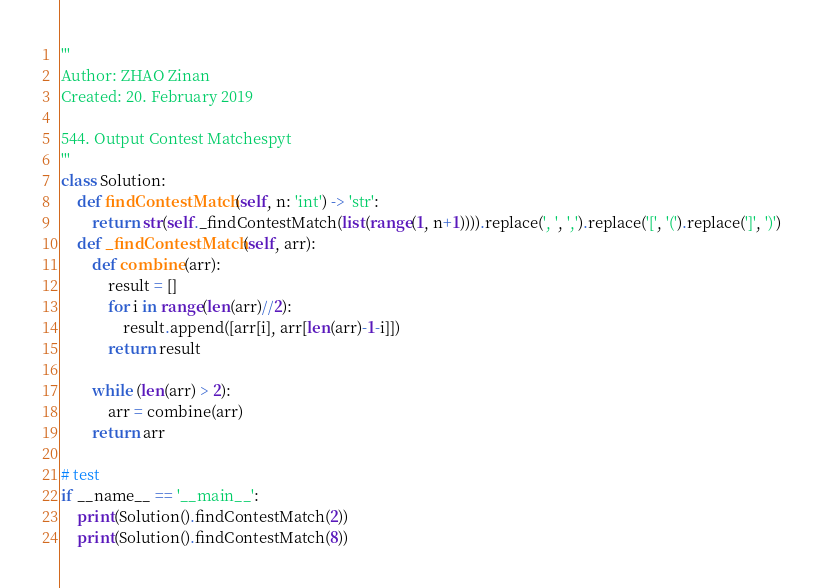Convert code to text. <code><loc_0><loc_0><loc_500><loc_500><_Python_>'''
Author: ZHAO Zinan
Created: 20. February 2019

544. Output Contest Matchespyt
''' 
class Solution:
    def findContestMatch(self, n: 'int') -> 'str':
        return str(self._findContestMatch(list(range(1, n+1)))).replace(', ', ',').replace('[', '(').replace(']', ')')
    def _findContestMatch(self, arr):
        def combine(arr):
            result = []
            for i in range(len(arr)//2):
                result.append([arr[i], arr[len(arr)-1-i]])
            return result

        while (len(arr) > 2):
            arr = combine(arr)
        return arr

# test
if __name__ == '__main__':
    print(Solution().findContestMatch(2))
    print(Solution().findContestMatch(8))

</code> 